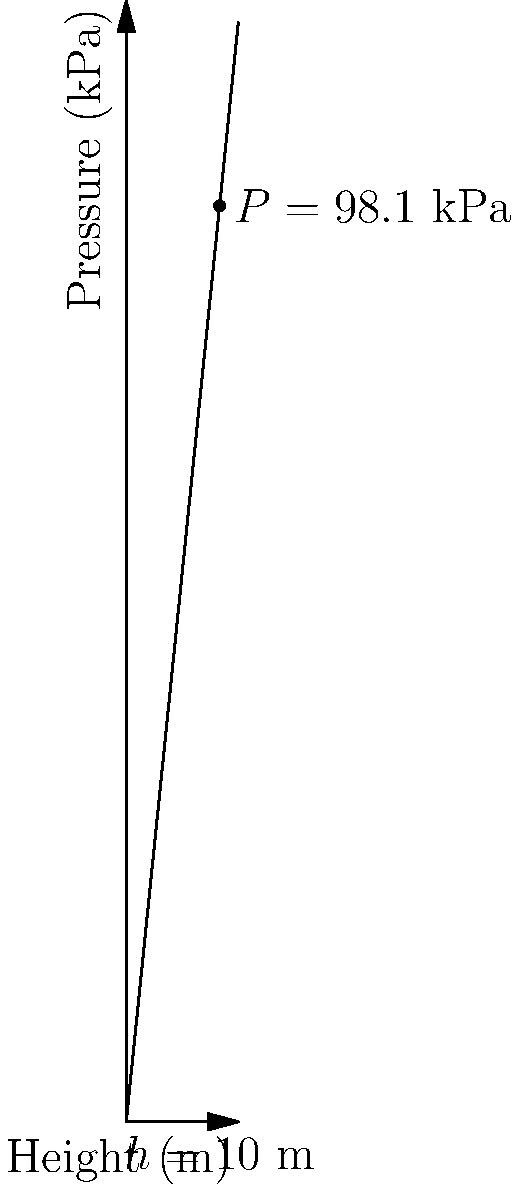In your dental office, you're curious about the water pressure in the pipes. The building is 10 meters tall, and you want to estimate the water pressure at ground level. Assuming the water tank is on the roof and neglecting any pressure losses, what would be the approximate water pressure (in kPa) at the ground floor? To estimate the water pressure, we'll use the following steps:

1. Recall the formula for hydrostatic pressure:
   $P = \rho g h$

   Where:
   $P$ = pressure (Pa)
   $\rho$ (rho) = density of water (1000 kg/m³)
   $g$ = acceleration due to gravity (9.81 m/s²)
   $h$ = height of the water column (m)

2. Insert the known values:
   $\rho = 1000$ kg/m³
   $g = 9.81$ m/s²
   $h = 10$ m (height of the building)

3. Calculate the pressure:
   $P = 1000 \text{ kg/m³} \times 9.81 \text{ m/s²} \times 10 \text{ m}$
   $P = 98100 \text{ Pa}$

4. Convert Pa to kPa:
   $98100 \text{ Pa} = 98.1 \text{ kPa}$

Therefore, the approximate water pressure at the ground floor would be 98.1 kPa.
Answer: 98.1 kPa 